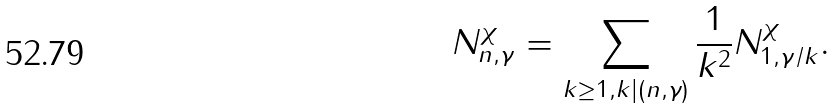Convert formula to latex. <formula><loc_0><loc_0><loc_500><loc_500>N _ { n , \gamma } ^ { \chi } = \sum _ { k \geq 1 , k | ( n , \gamma ) } \frac { 1 } { k ^ { 2 } } N _ { 1 , \gamma / k } ^ { \chi } .</formula> 